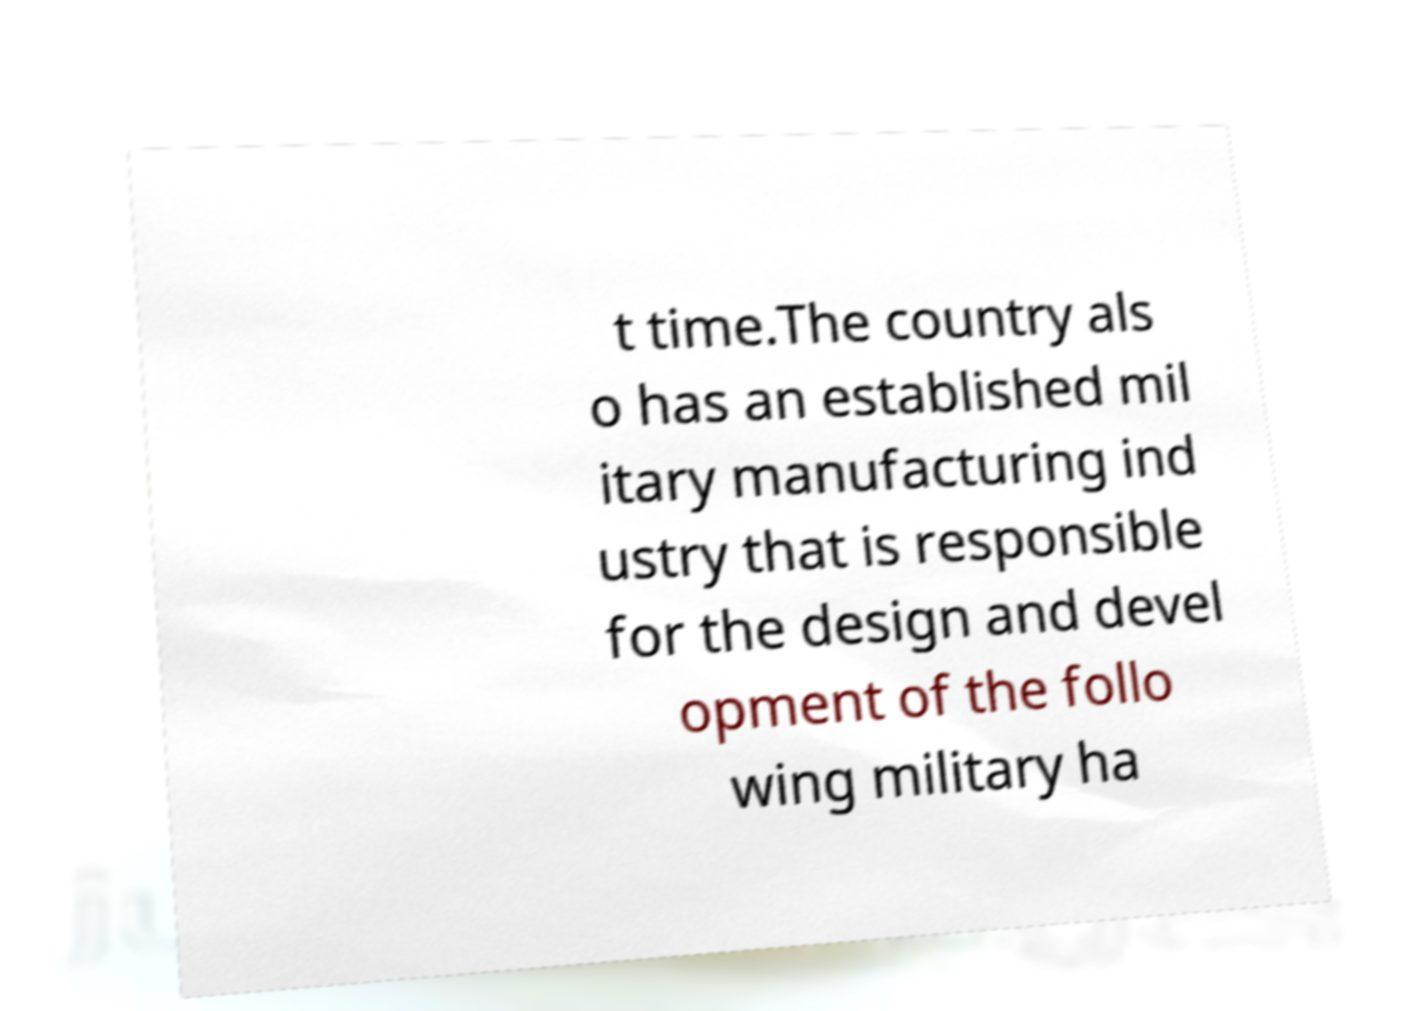What messages or text are displayed in this image? I need them in a readable, typed format. t time.The country als o has an established mil itary manufacturing ind ustry that is responsible for the design and devel opment of the follo wing military ha 